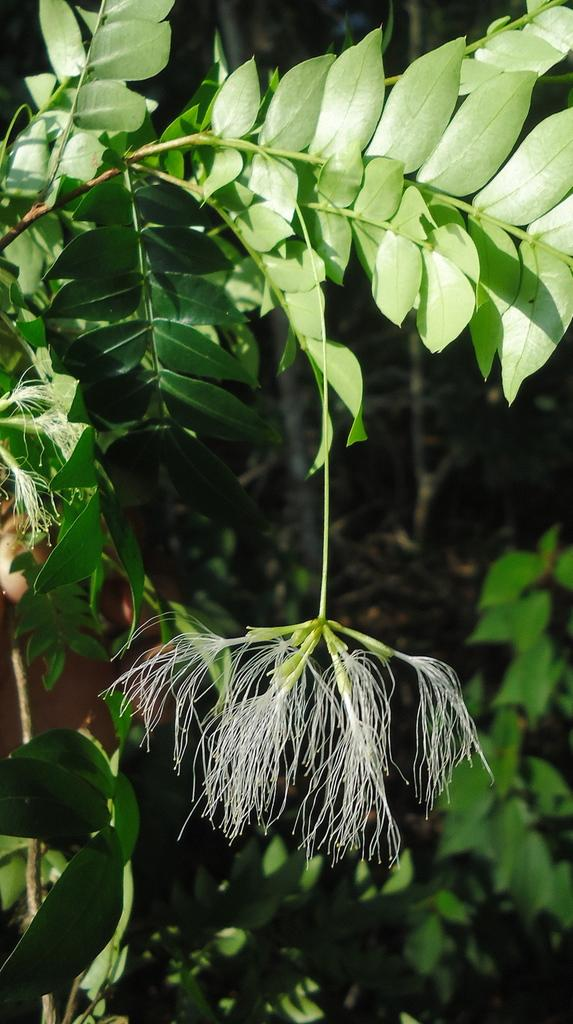What type of plant material is visible in the image? There are leaves of plants in the image. What other botanical element can be seen in the image? There is a flower in the image. Where is the throne located in the image? There is no throne present in the image. How does the sand contribute to the comfort of the plants in the image? There is no sand present in the image, so it cannot contribute to the comfort of the plants. 